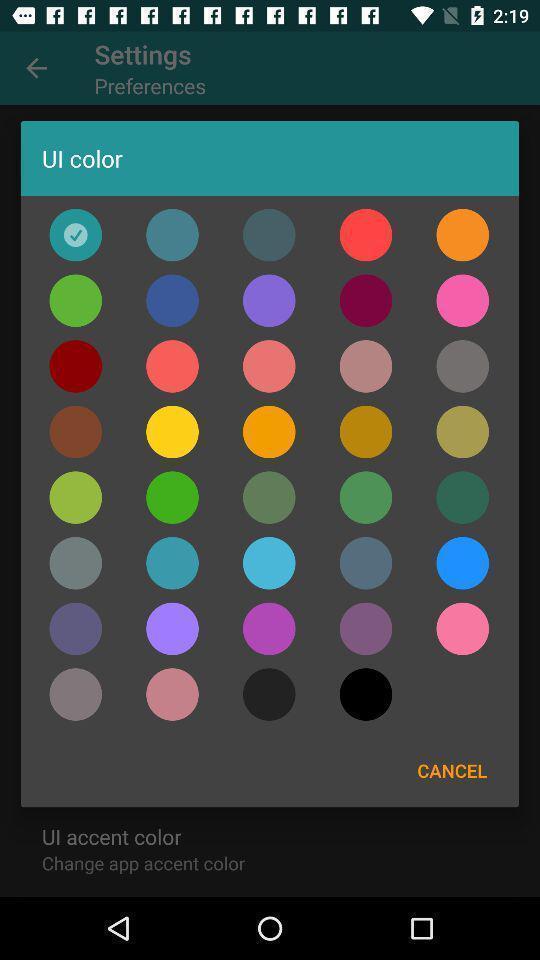Provide a textual representation of this image. Pop-up screen displaying with different color options. 